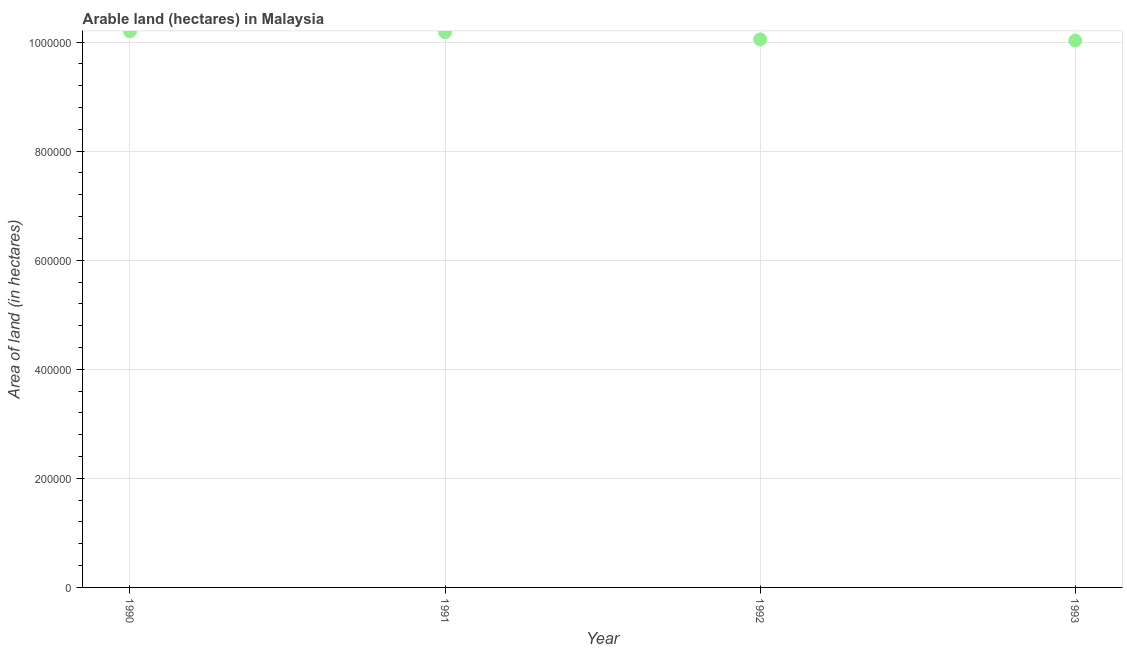What is the area of land in 1990?
Provide a short and direct response. 1.02e+06. Across all years, what is the maximum area of land?
Provide a short and direct response. 1.02e+06. Across all years, what is the minimum area of land?
Ensure brevity in your answer.  1.00e+06. In which year was the area of land maximum?
Make the answer very short. 1990. What is the sum of the area of land?
Ensure brevity in your answer.  4.05e+06. What is the difference between the area of land in 1990 and 1992?
Ensure brevity in your answer.  1.49e+04. What is the average area of land per year?
Your response must be concise. 1.01e+06. What is the median area of land?
Offer a very short reply. 1.01e+06. In how many years, is the area of land greater than 240000 hectares?
Offer a very short reply. 4. What is the ratio of the area of land in 1991 to that in 1992?
Provide a succinct answer. 1.01. What is the difference between the highest and the second highest area of land?
Provide a succinct answer. 1700. What is the difference between the highest and the lowest area of land?
Provide a short and direct response. 1.70e+04. In how many years, is the area of land greater than the average area of land taken over all years?
Ensure brevity in your answer.  2. How many dotlines are there?
Your answer should be compact. 1. Are the values on the major ticks of Y-axis written in scientific E-notation?
Offer a terse response. No. Does the graph contain any zero values?
Give a very brief answer. No. What is the title of the graph?
Give a very brief answer. Arable land (hectares) in Malaysia. What is the label or title of the Y-axis?
Your response must be concise. Area of land (in hectares). What is the Area of land (in hectares) in 1990?
Give a very brief answer. 1.02e+06. What is the Area of land (in hectares) in 1991?
Your response must be concise. 1.02e+06. What is the Area of land (in hectares) in 1992?
Make the answer very short. 1.00e+06. What is the Area of land (in hectares) in 1993?
Make the answer very short. 1.00e+06. What is the difference between the Area of land (in hectares) in 1990 and 1991?
Your response must be concise. 1700. What is the difference between the Area of land (in hectares) in 1990 and 1992?
Make the answer very short. 1.49e+04. What is the difference between the Area of land (in hectares) in 1990 and 1993?
Make the answer very short. 1.70e+04. What is the difference between the Area of land (in hectares) in 1991 and 1992?
Your answer should be compact. 1.32e+04. What is the difference between the Area of land (in hectares) in 1991 and 1993?
Offer a very short reply. 1.53e+04. What is the difference between the Area of land (in hectares) in 1992 and 1993?
Provide a succinct answer. 2100. What is the ratio of the Area of land (in hectares) in 1991 to that in 1993?
Offer a terse response. 1.01. 